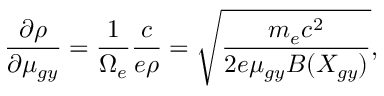<formula> <loc_0><loc_0><loc_500><loc_500>\frac { \partial \rho } { \partial \mu _ { g y } } = \frac { 1 } { \Omega _ { e } } \frac { c } { e \rho } = \sqrt { \frac { m _ { e } c ^ { 2 } } { 2 e \mu _ { g y } B ( X _ { g y } ) } } ,</formula> 